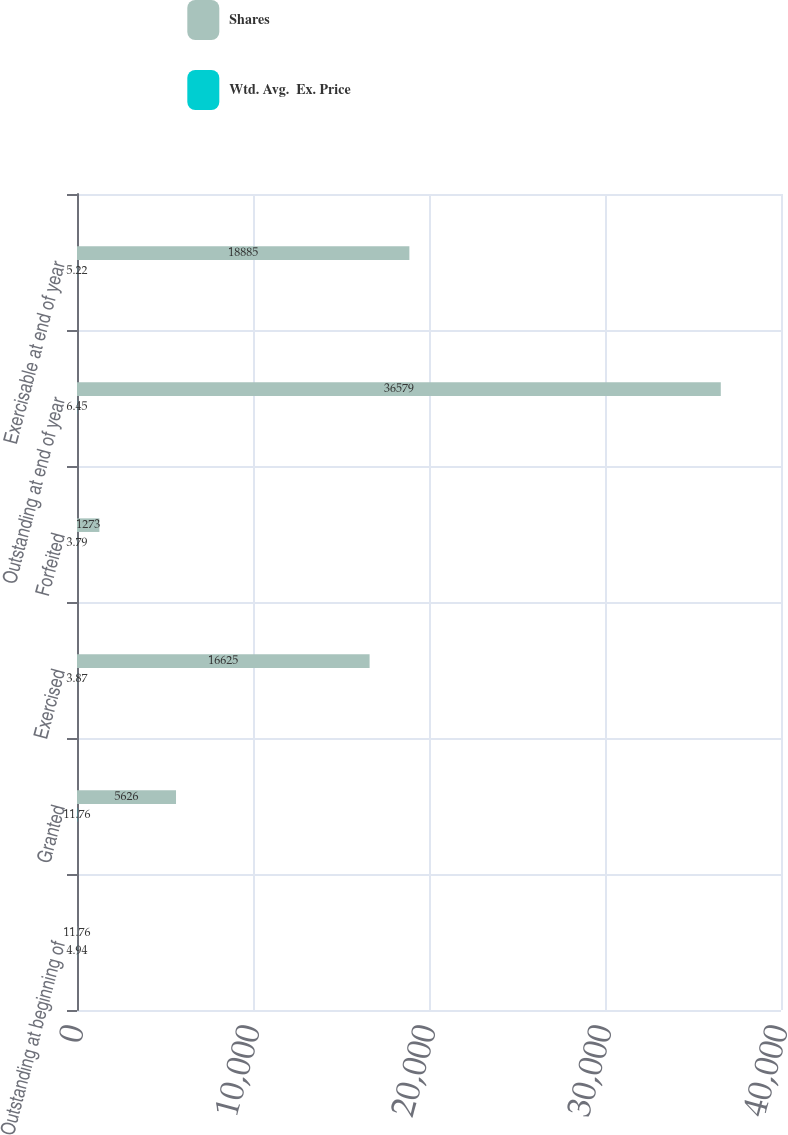Convert chart. <chart><loc_0><loc_0><loc_500><loc_500><stacked_bar_chart><ecel><fcel>Outstanding at beginning of<fcel>Granted<fcel>Exercised<fcel>Forfeited<fcel>Outstanding at end of year<fcel>Exercisable at end of year<nl><fcel>Shares<fcel>11.76<fcel>5626<fcel>16625<fcel>1273<fcel>36579<fcel>18885<nl><fcel>Wtd. Avg.  Ex. Price<fcel>4.94<fcel>11.76<fcel>3.87<fcel>3.79<fcel>6.45<fcel>5.22<nl></chart> 